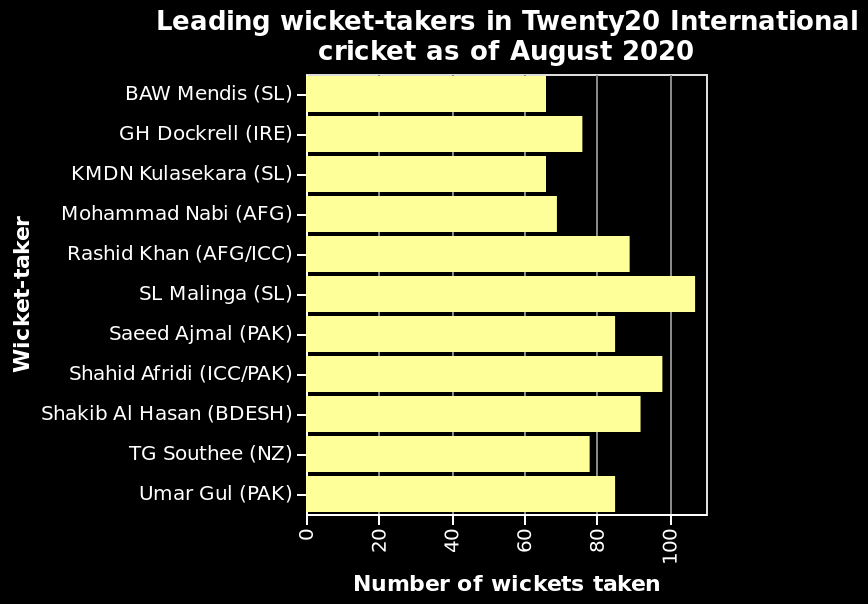<image>
What does the y-axis of the bar plot represent? The y-axis represents the "Wicket-taker" in the bar plot. What is the highest number of wickets taken by any wicker-taker?  The highest number of wickets taken by any wicker-taker is above 100. 